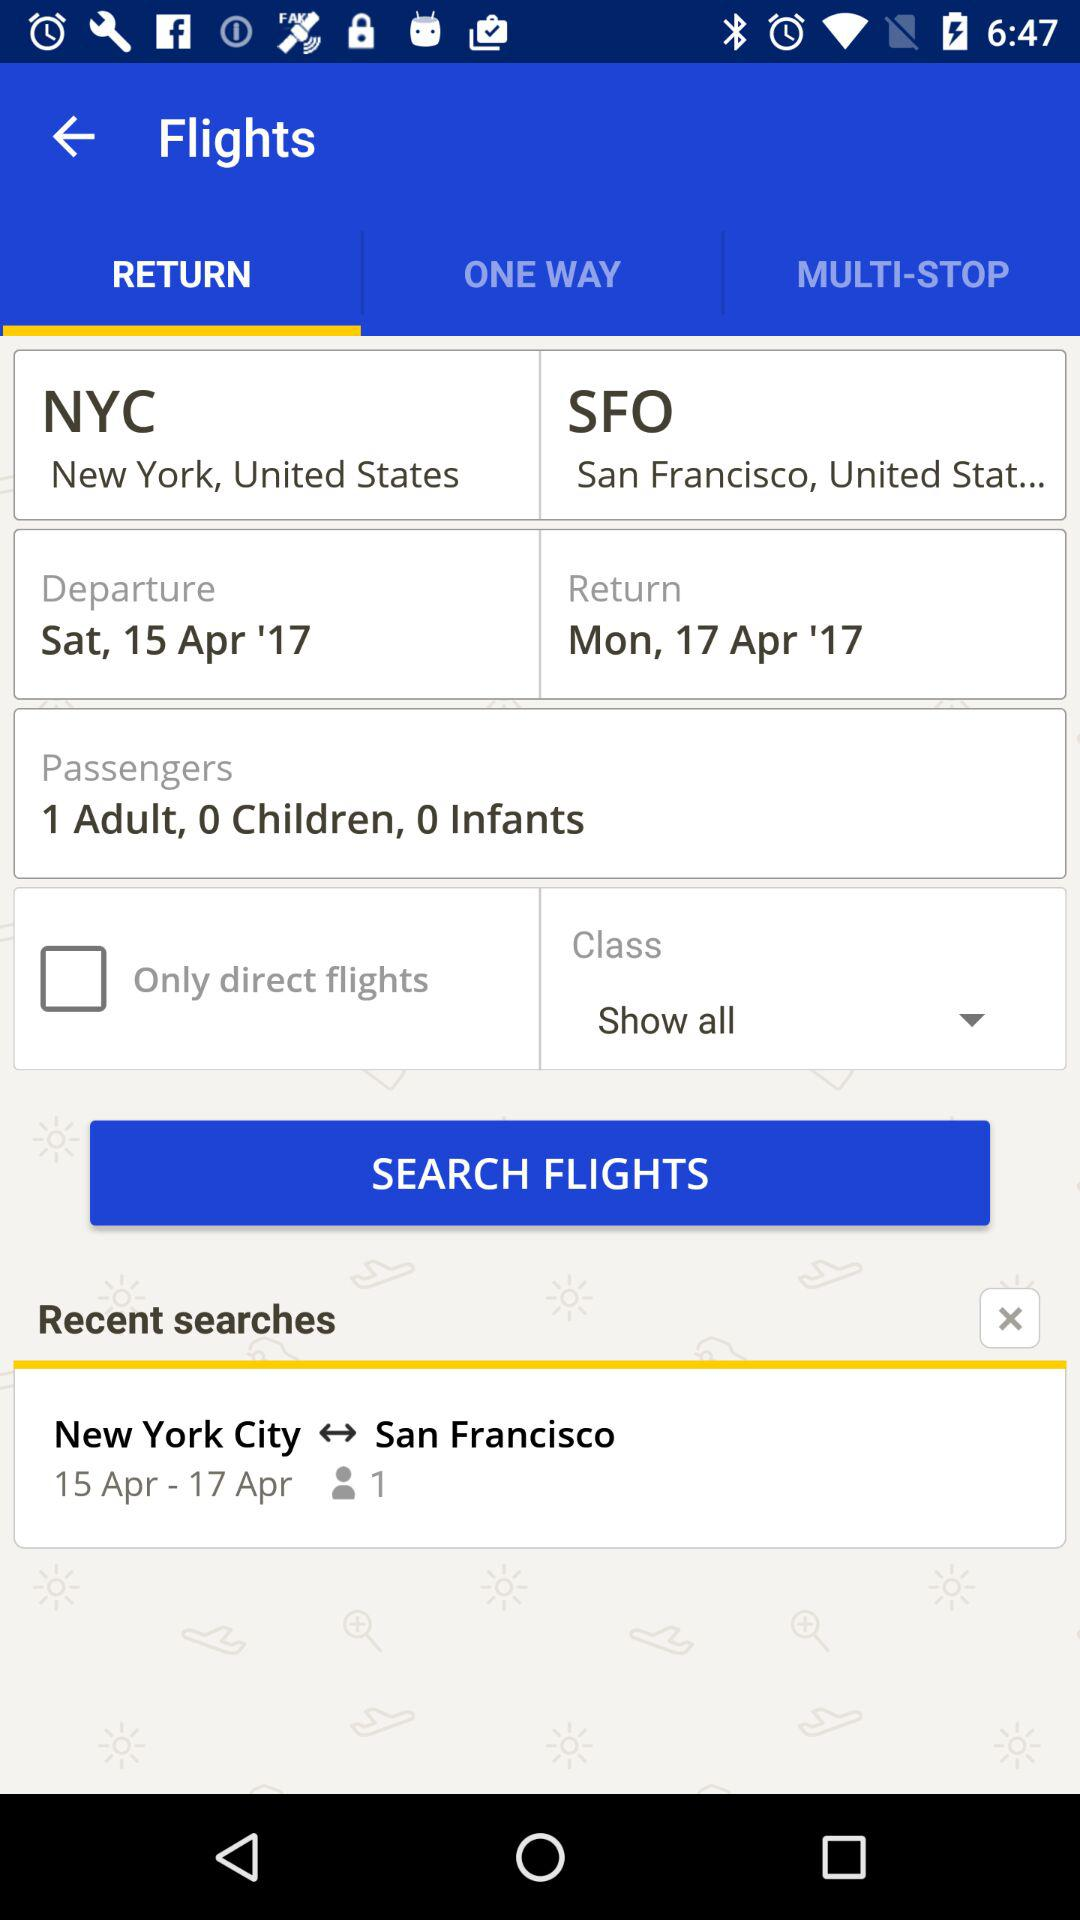What is the departure date? The departure date is Saturday, April 15, 2017. 